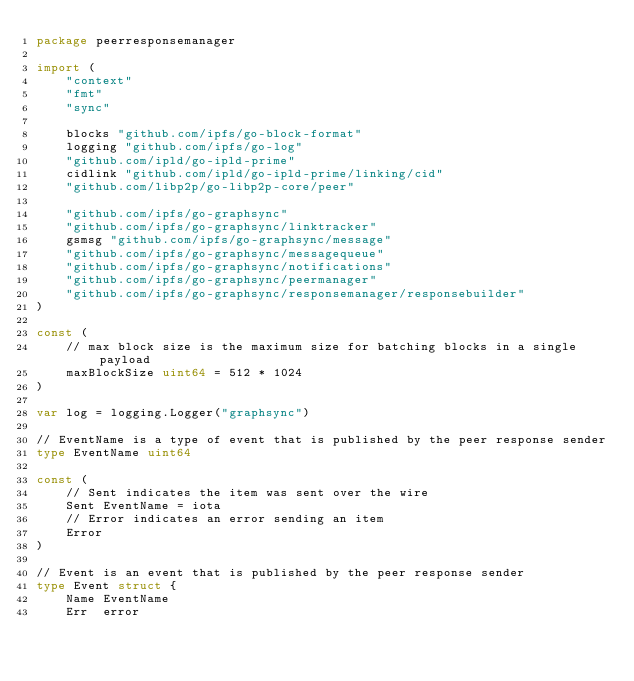Convert code to text. <code><loc_0><loc_0><loc_500><loc_500><_Go_>package peerresponsemanager

import (
	"context"
	"fmt"
	"sync"

	blocks "github.com/ipfs/go-block-format"
	logging "github.com/ipfs/go-log"
	"github.com/ipld/go-ipld-prime"
	cidlink "github.com/ipld/go-ipld-prime/linking/cid"
	"github.com/libp2p/go-libp2p-core/peer"

	"github.com/ipfs/go-graphsync"
	"github.com/ipfs/go-graphsync/linktracker"
	gsmsg "github.com/ipfs/go-graphsync/message"
	"github.com/ipfs/go-graphsync/messagequeue"
	"github.com/ipfs/go-graphsync/notifications"
	"github.com/ipfs/go-graphsync/peermanager"
	"github.com/ipfs/go-graphsync/responsemanager/responsebuilder"
)

const (
	// max block size is the maximum size for batching blocks in a single payload
	maxBlockSize uint64 = 512 * 1024
)

var log = logging.Logger("graphsync")

// EventName is a type of event that is published by the peer response sender
type EventName uint64

const (
	// Sent indicates the item was sent over the wire
	Sent EventName = iota
	// Error indicates an error sending an item
	Error
)

// Event is an event that is published by the peer response sender
type Event struct {
	Name EventName
	Err  error</code> 